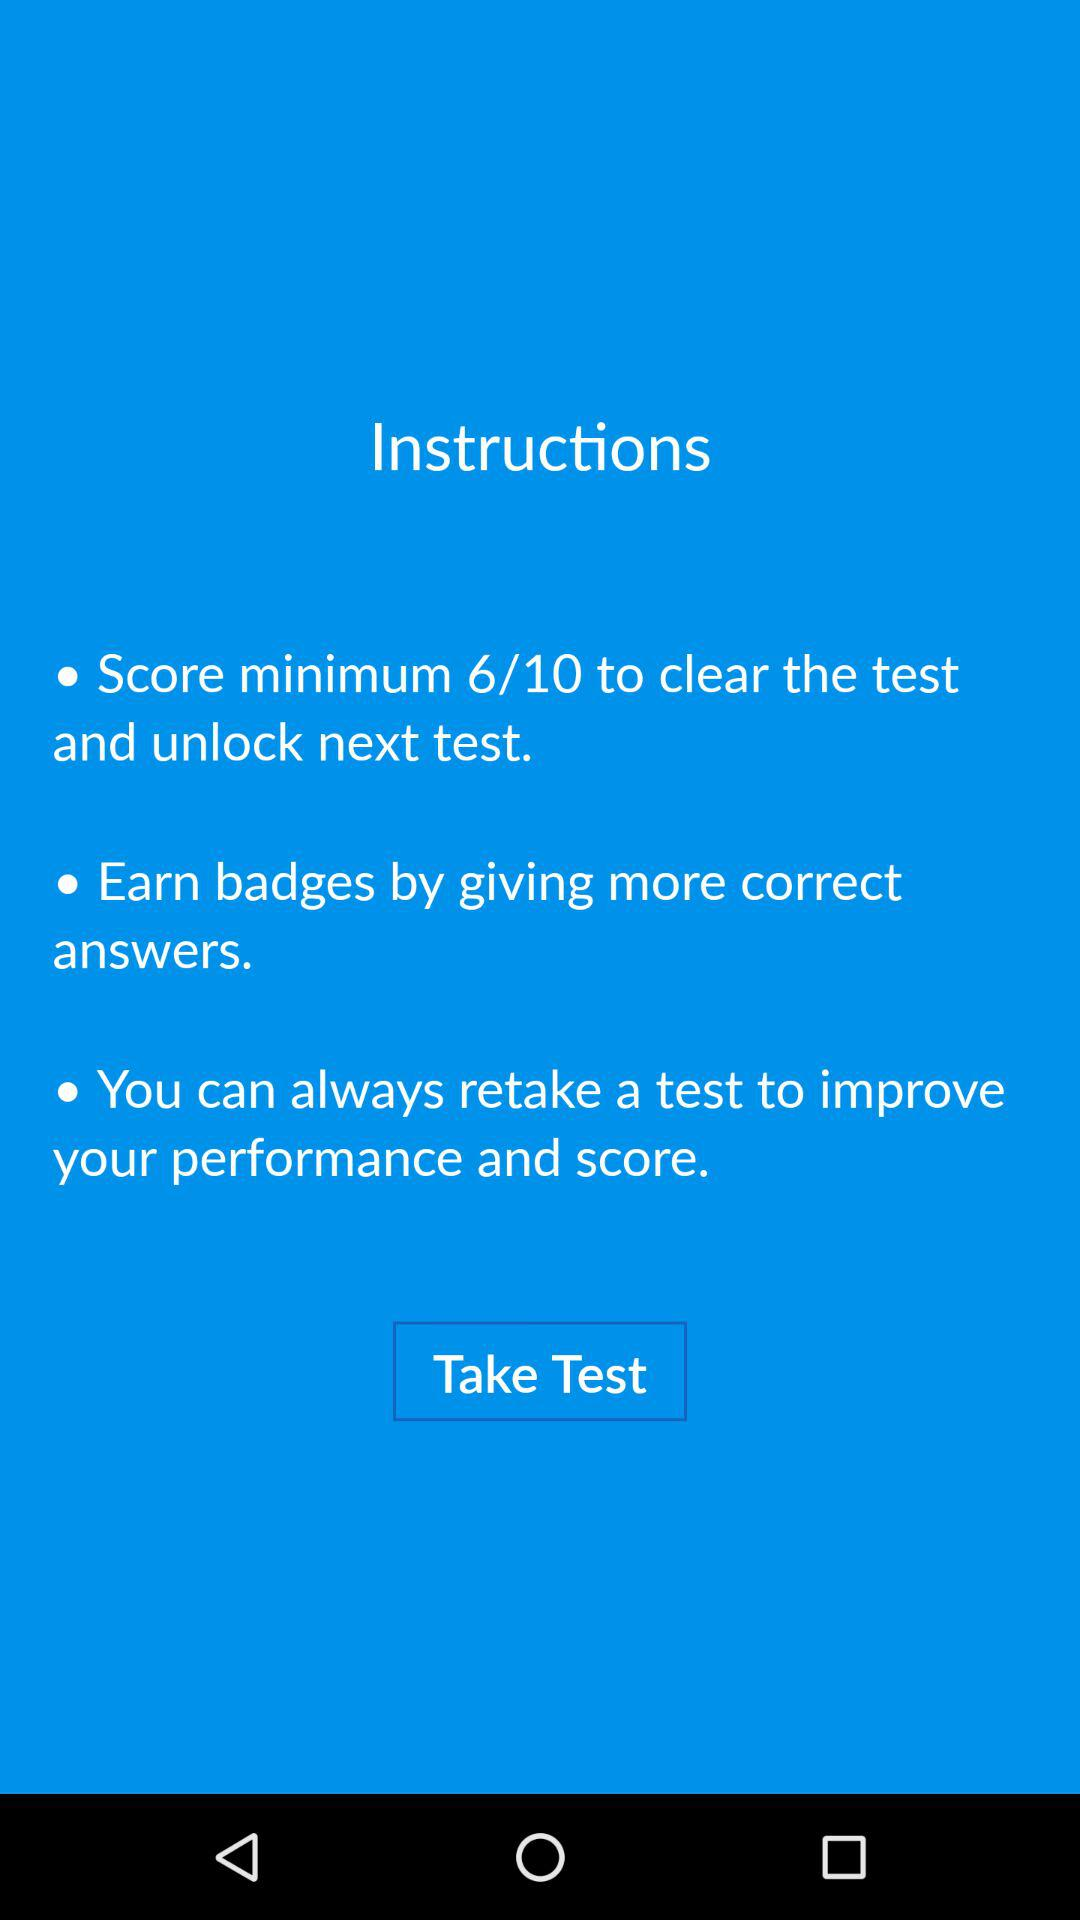How many instructions are there?
Answer the question using a single word or phrase. 3 